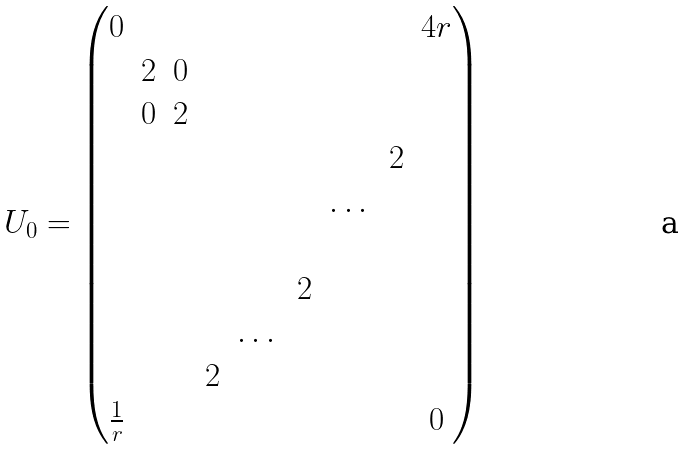Convert formula to latex. <formula><loc_0><loc_0><loc_500><loc_500>U _ { 0 } = \begin{pmatrix} 0 & & & & & & & & 4 r \\ & 2 & 0 & & & & & & \\ & 0 & 2 & & & & & & \\ & & & & & & & 2 & \\ & & & & & & \dots & & \\ & & & & & & & & \\ & & & & & 2 & & & \\ & & & & \dots & & & & \\ & & & 2 & & & & & \\ \frac { 1 } { r } & & & & & & & & 0 \\ \end{pmatrix}</formula> 